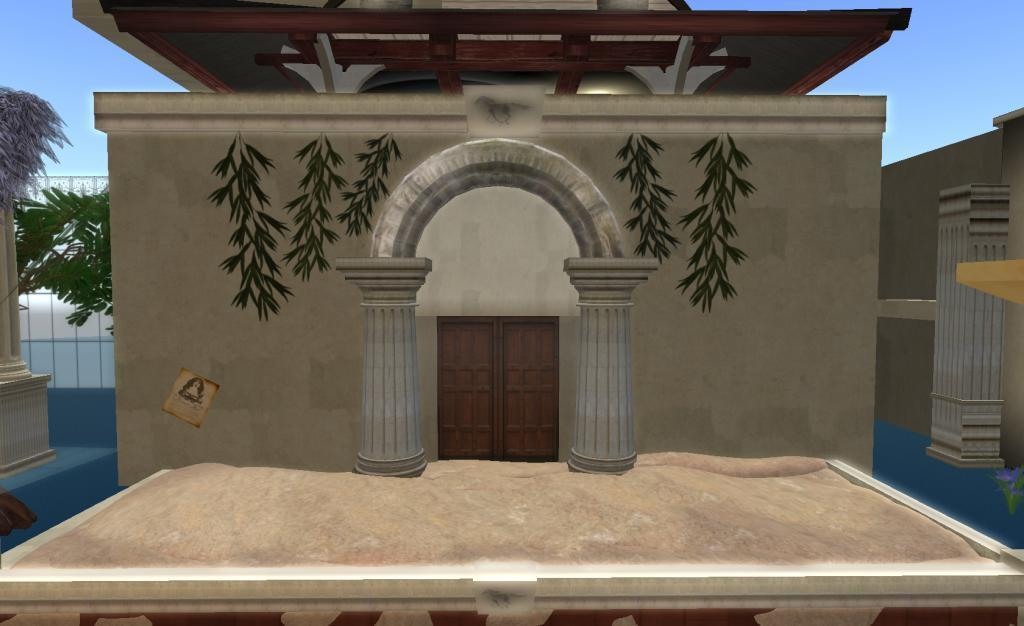What type of picture is in the image? The image contains an animation picture. What structures can be seen in the image? There are buildings in the image. What type of vegetation is present in the image? There are trees in the image. What type of barrier is in the image? There is fencing in the image. What is the color of the sky in the image? The sky is blue and white in color. What is the price of the father's account in the image? There is no mention of a father or an account in the image, so it is not possible to determine the price. 